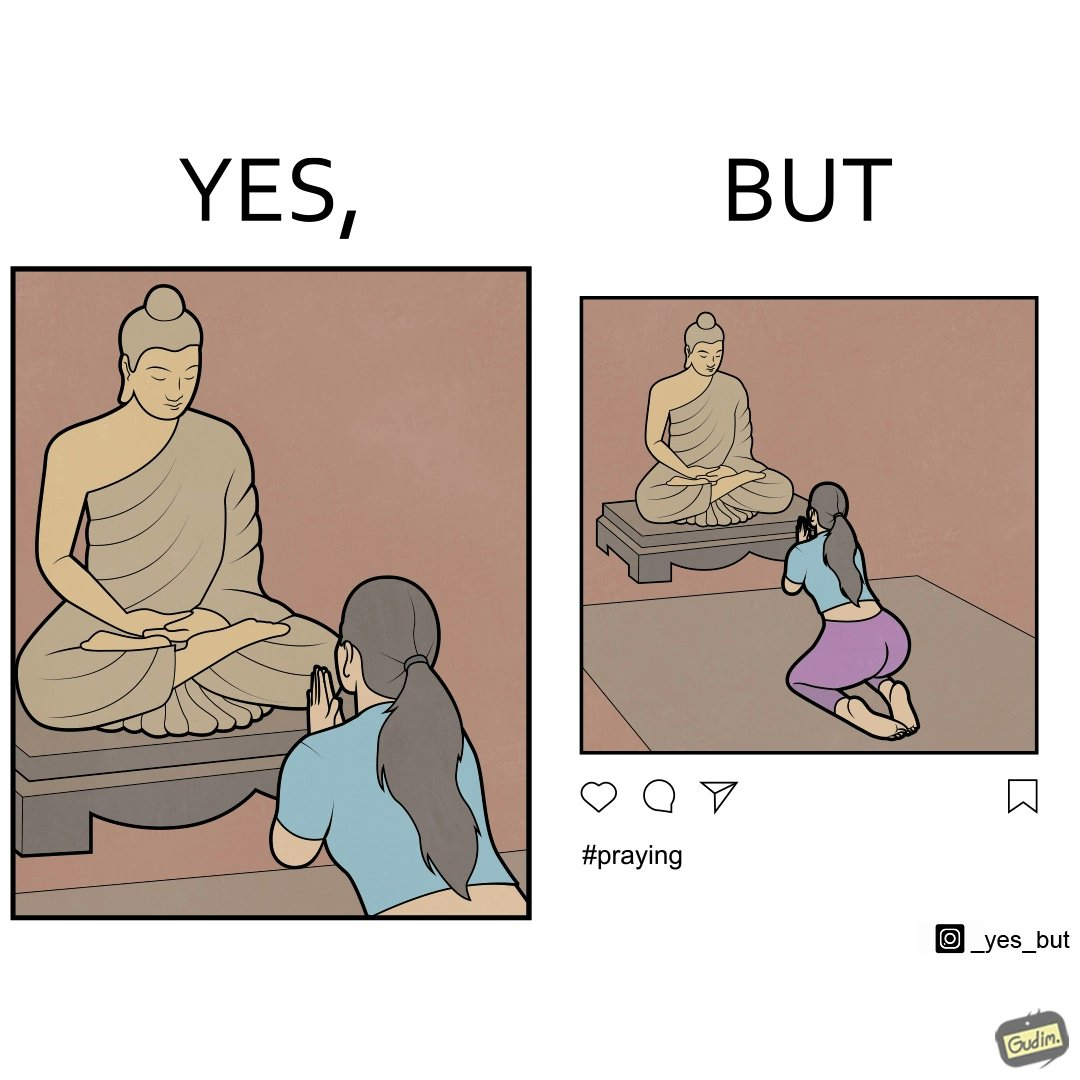Why is this image considered satirical? The image is ironic, because in the first image it seems that the woman is praying whole heartedly by bowing down in front of the statue but in the second image the same image is seen posted on the internet, so the woman was just posing for a photo to be posted on internet to gain followers or likes 